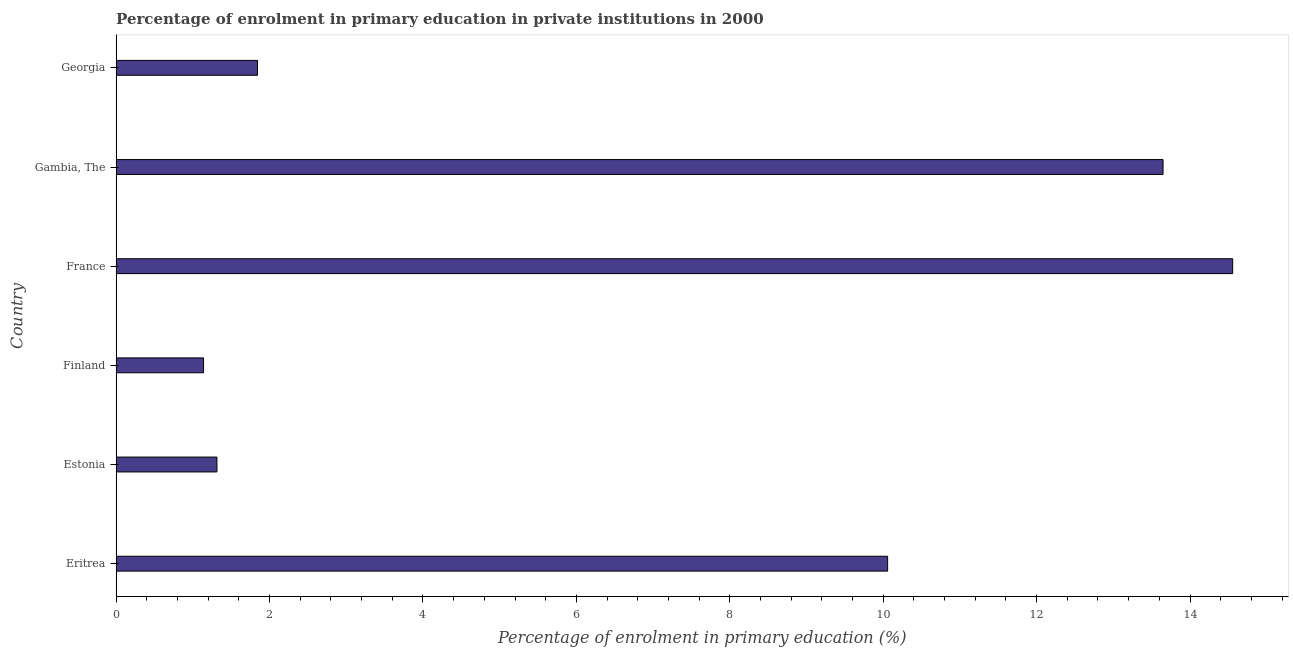What is the title of the graph?
Your answer should be very brief. Percentage of enrolment in primary education in private institutions in 2000. What is the label or title of the X-axis?
Ensure brevity in your answer.  Percentage of enrolment in primary education (%). What is the label or title of the Y-axis?
Provide a short and direct response. Country. What is the enrolment percentage in primary education in Eritrea?
Offer a terse response. 10.06. Across all countries, what is the maximum enrolment percentage in primary education?
Provide a succinct answer. 14.56. Across all countries, what is the minimum enrolment percentage in primary education?
Your answer should be compact. 1.14. In which country was the enrolment percentage in primary education maximum?
Offer a terse response. France. In which country was the enrolment percentage in primary education minimum?
Your response must be concise. Finland. What is the sum of the enrolment percentage in primary education?
Provide a short and direct response. 42.56. What is the difference between the enrolment percentage in primary education in Estonia and Finland?
Make the answer very short. 0.17. What is the average enrolment percentage in primary education per country?
Keep it short and to the point. 7.09. What is the median enrolment percentage in primary education?
Provide a short and direct response. 5.95. What is the ratio of the enrolment percentage in primary education in Eritrea to that in Finland?
Ensure brevity in your answer.  8.83. Is the enrolment percentage in primary education in Finland less than that in Georgia?
Make the answer very short. Yes. What is the difference between the highest and the second highest enrolment percentage in primary education?
Make the answer very short. 0.91. Is the sum of the enrolment percentage in primary education in Finland and France greater than the maximum enrolment percentage in primary education across all countries?
Give a very brief answer. Yes. What is the difference between the highest and the lowest enrolment percentage in primary education?
Offer a terse response. 13.42. In how many countries, is the enrolment percentage in primary education greater than the average enrolment percentage in primary education taken over all countries?
Ensure brevity in your answer.  3. How many bars are there?
Your response must be concise. 6. Are all the bars in the graph horizontal?
Offer a very short reply. Yes. Are the values on the major ticks of X-axis written in scientific E-notation?
Ensure brevity in your answer.  No. What is the Percentage of enrolment in primary education (%) in Eritrea?
Ensure brevity in your answer.  10.06. What is the Percentage of enrolment in primary education (%) of Estonia?
Your response must be concise. 1.31. What is the Percentage of enrolment in primary education (%) of Finland?
Ensure brevity in your answer.  1.14. What is the Percentage of enrolment in primary education (%) of France?
Your answer should be compact. 14.56. What is the Percentage of enrolment in primary education (%) of Gambia, The?
Your answer should be very brief. 13.65. What is the Percentage of enrolment in primary education (%) of Georgia?
Provide a succinct answer. 1.84. What is the difference between the Percentage of enrolment in primary education (%) in Eritrea and Estonia?
Offer a very short reply. 8.74. What is the difference between the Percentage of enrolment in primary education (%) in Eritrea and Finland?
Offer a terse response. 8.92. What is the difference between the Percentage of enrolment in primary education (%) in Eritrea and France?
Make the answer very short. -4.5. What is the difference between the Percentage of enrolment in primary education (%) in Eritrea and Gambia, The?
Your response must be concise. -3.59. What is the difference between the Percentage of enrolment in primary education (%) in Eritrea and Georgia?
Provide a succinct answer. 8.21. What is the difference between the Percentage of enrolment in primary education (%) in Estonia and Finland?
Your response must be concise. 0.17. What is the difference between the Percentage of enrolment in primary education (%) in Estonia and France?
Ensure brevity in your answer.  -13.24. What is the difference between the Percentage of enrolment in primary education (%) in Estonia and Gambia, The?
Provide a short and direct response. -12.33. What is the difference between the Percentage of enrolment in primary education (%) in Estonia and Georgia?
Give a very brief answer. -0.53. What is the difference between the Percentage of enrolment in primary education (%) in Finland and France?
Your response must be concise. -13.42. What is the difference between the Percentage of enrolment in primary education (%) in Finland and Gambia, The?
Offer a terse response. -12.51. What is the difference between the Percentage of enrolment in primary education (%) in Finland and Georgia?
Offer a terse response. -0.7. What is the difference between the Percentage of enrolment in primary education (%) in France and Gambia, The?
Keep it short and to the point. 0.91. What is the difference between the Percentage of enrolment in primary education (%) in France and Georgia?
Ensure brevity in your answer.  12.71. What is the difference between the Percentage of enrolment in primary education (%) in Gambia, The and Georgia?
Keep it short and to the point. 11.81. What is the ratio of the Percentage of enrolment in primary education (%) in Eritrea to that in Estonia?
Ensure brevity in your answer.  7.65. What is the ratio of the Percentage of enrolment in primary education (%) in Eritrea to that in Finland?
Keep it short and to the point. 8.83. What is the ratio of the Percentage of enrolment in primary education (%) in Eritrea to that in France?
Keep it short and to the point. 0.69. What is the ratio of the Percentage of enrolment in primary education (%) in Eritrea to that in Gambia, The?
Provide a short and direct response. 0.74. What is the ratio of the Percentage of enrolment in primary education (%) in Eritrea to that in Georgia?
Give a very brief answer. 5.46. What is the ratio of the Percentage of enrolment in primary education (%) in Estonia to that in Finland?
Offer a terse response. 1.15. What is the ratio of the Percentage of enrolment in primary education (%) in Estonia to that in France?
Provide a succinct answer. 0.09. What is the ratio of the Percentage of enrolment in primary education (%) in Estonia to that in Gambia, The?
Give a very brief answer. 0.1. What is the ratio of the Percentage of enrolment in primary education (%) in Estonia to that in Georgia?
Provide a short and direct response. 0.71. What is the ratio of the Percentage of enrolment in primary education (%) in Finland to that in France?
Offer a very short reply. 0.08. What is the ratio of the Percentage of enrolment in primary education (%) in Finland to that in Gambia, The?
Your response must be concise. 0.08. What is the ratio of the Percentage of enrolment in primary education (%) in Finland to that in Georgia?
Offer a very short reply. 0.62. What is the ratio of the Percentage of enrolment in primary education (%) in France to that in Gambia, The?
Offer a very short reply. 1.07. What is the ratio of the Percentage of enrolment in primary education (%) in France to that in Georgia?
Your answer should be compact. 7.9. What is the ratio of the Percentage of enrolment in primary education (%) in Gambia, The to that in Georgia?
Ensure brevity in your answer.  7.41. 